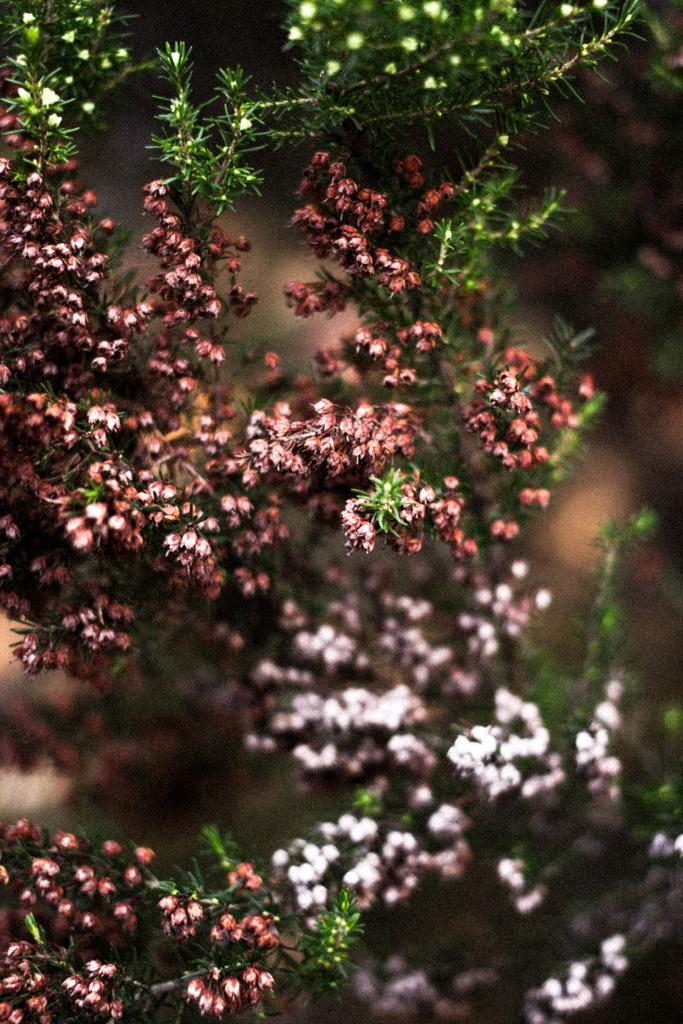What type of living organisms can be seen in the image? There are flowers and plants visible in the image. Can you describe the plants in the image? The plants in the image are not specified, but they are present alongside the flowers. What type of harmony is being achieved by the plants in the image? There is no indication of harmony or any specific interaction between the plants in the image. 